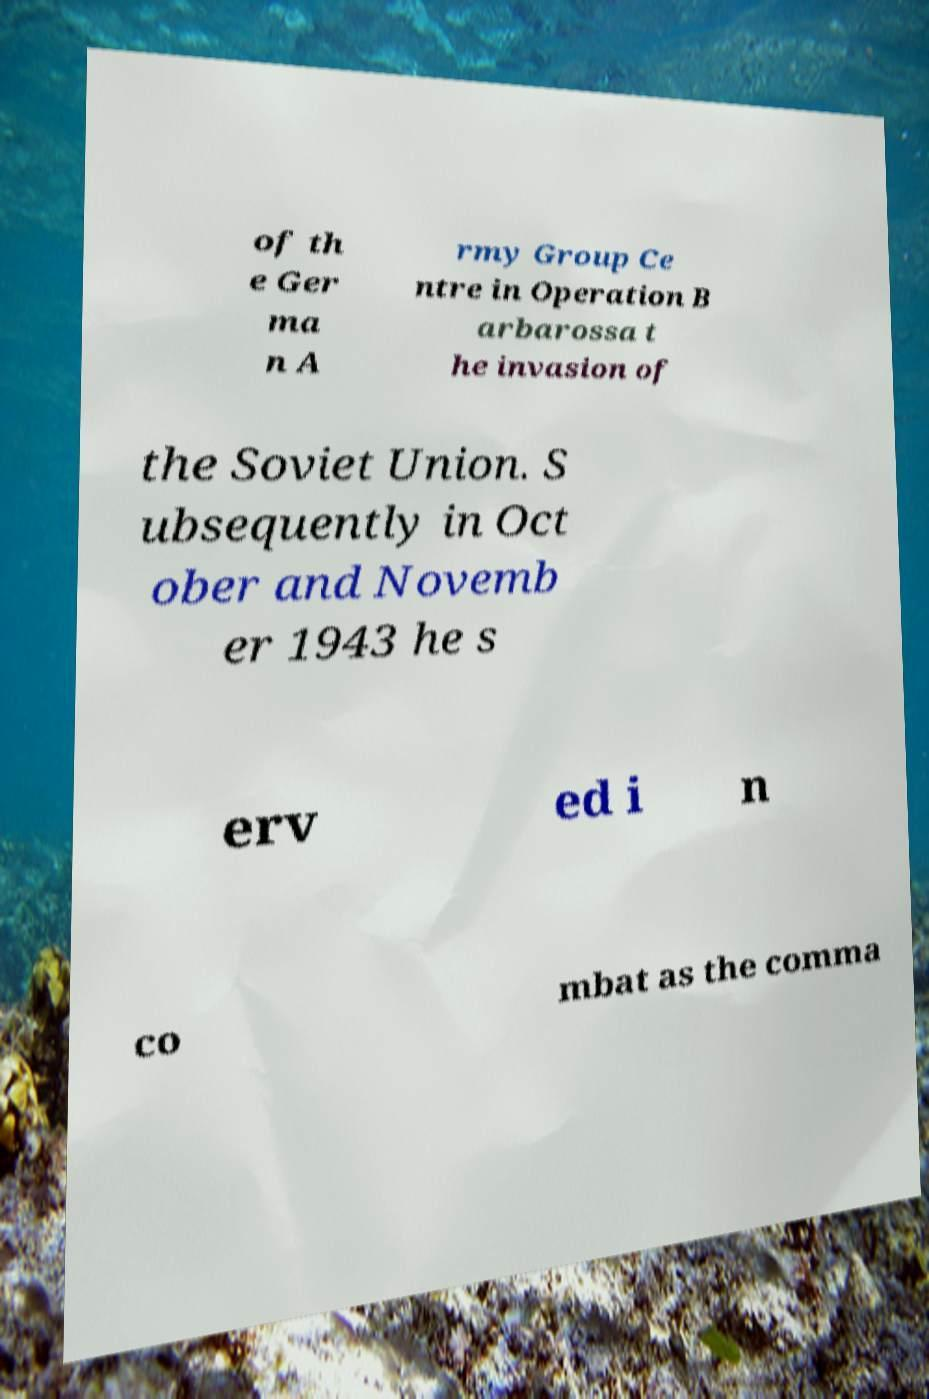There's text embedded in this image that I need extracted. Can you transcribe it verbatim? of th e Ger ma n A rmy Group Ce ntre in Operation B arbarossa t he invasion of the Soviet Union. S ubsequently in Oct ober and Novemb er 1943 he s erv ed i n co mbat as the comma 